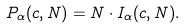Convert formula to latex. <formula><loc_0><loc_0><loc_500><loc_500>P _ { \alpha } ( c , N ) = N \cdot I _ { \alpha } ( c , N ) .</formula> 